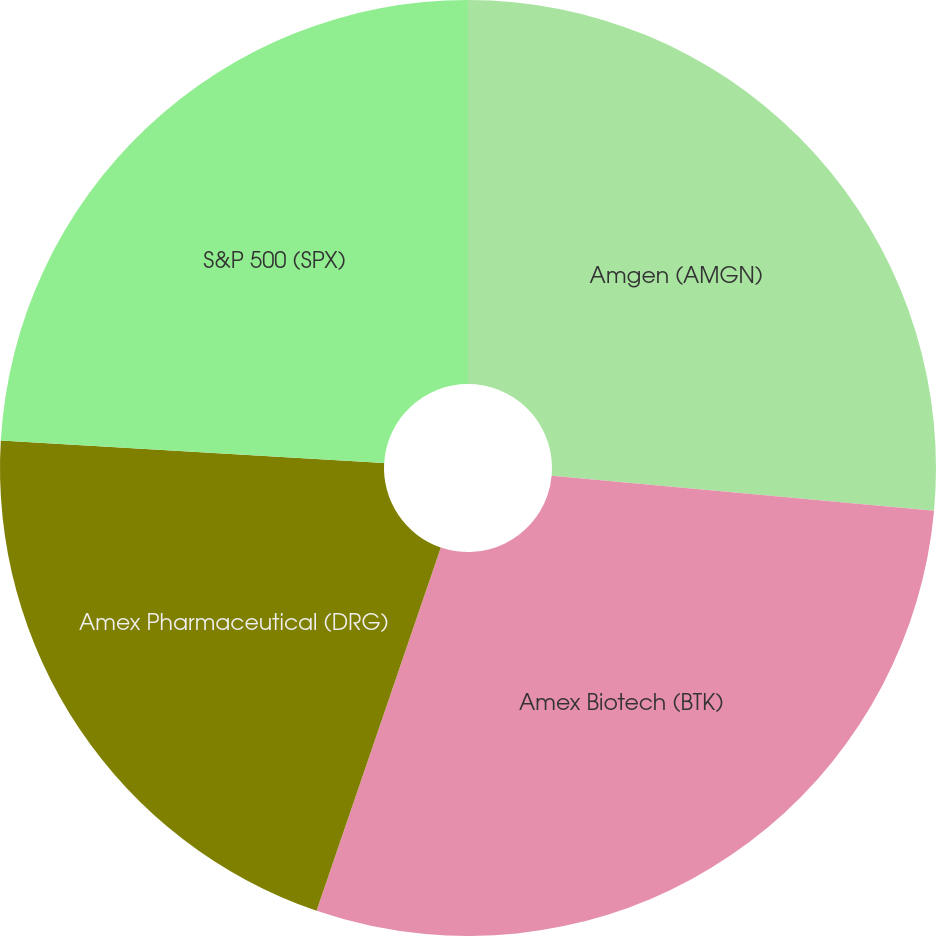Convert chart. <chart><loc_0><loc_0><loc_500><loc_500><pie_chart><fcel>Amgen (AMGN)<fcel>Amex Biotech (BTK)<fcel>Amex Pharmaceutical (DRG)<fcel>S&P 500 (SPX)<nl><fcel>26.45%<fcel>28.79%<fcel>20.69%<fcel>24.06%<nl></chart> 